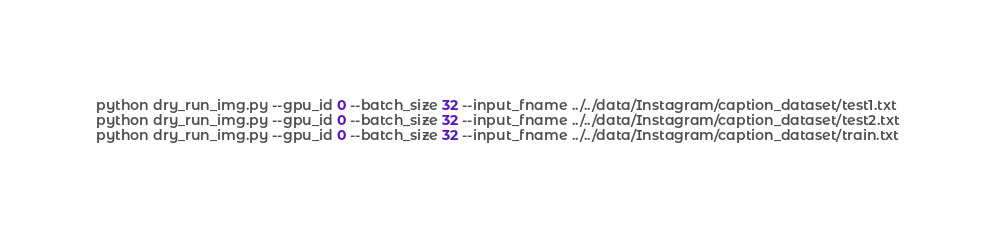<code> <loc_0><loc_0><loc_500><loc_500><_Bash_>python dry_run_img.py --gpu_id 0 --batch_size 32 --input_fname ../../data/Instagram/caption_dataset/test1.txt
python dry_run_img.py --gpu_id 0 --batch_size 32 --input_fname ../../data/Instagram/caption_dataset/test2.txt
python dry_run_img.py --gpu_id 0 --batch_size 32 --input_fname ../../data/Instagram/caption_dataset/train.txt
</code> 